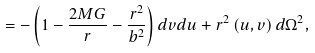<formula> <loc_0><loc_0><loc_500><loc_500>= - \left ( 1 - \frac { 2 M G } { r } - \frac { r ^ { 2 } } { b ^ { 2 } } \right ) d v d u + r ^ { 2 } \left ( u , v \right ) d \Omega ^ { 2 } ,</formula> 